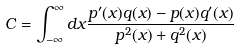<formula> <loc_0><loc_0><loc_500><loc_500>C = \int _ { - \infty } ^ { \infty } d x \frac { p ^ { \prime } ( x ) q ( x ) - p ( x ) q ^ { \prime } ( x ) } { p ^ { 2 } ( x ) + q ^ { 2 } ( x ) }</formula> 